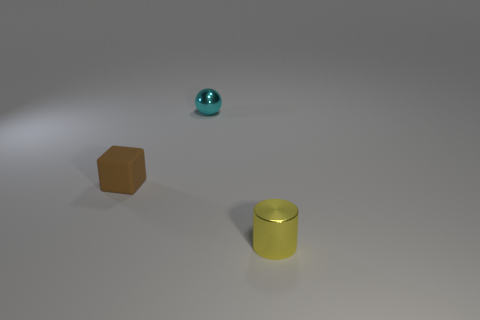Add 2 small yellow shiny things. How many objects exist? 5 Subtract 1 blocks. How many blocks are left? 0 Subtract all cylinders. How many objects are left? 2 Add 2 small blocks. How many small blocks are left? 3 Add 2 big gray metallic objects. How many big gray metallic objects exist? 2 Subtract 0 gray cubes. How many objects are left? 3 Subtract all green cylinders. Subtract all purple blocks. How many cylinders are left? 1 Subtract all tiny purple cubes. Subtract all brown cubes. How many objects are left? 2 